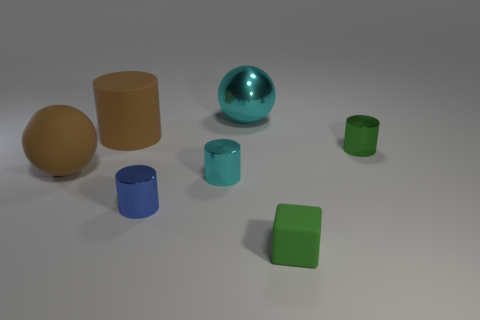Add 2 brown matte balls. How many objects exist? 9 Subtract all balls. How many objects are left? 5 Subtract 1 cubes. How many cubes are left? 0 Subtract all cyan spheres. Subtract all brown cubes. How many spheres are left? 1 Subtract all cyan cylinders. How many cyan spheres are left? 1 Subtract all rubber spheres. Subtract all big brown cylinders. How many objects are left? 5 Add 5 green rubber things. How many green rubber things are left? 6 Add 3 yellow cubes. How many yellow cubes exist? 3 Subtract all green cylinders. How many cylinders are left? 3 Subtract all blue metal cylinders. How many cylinders are left? 3 